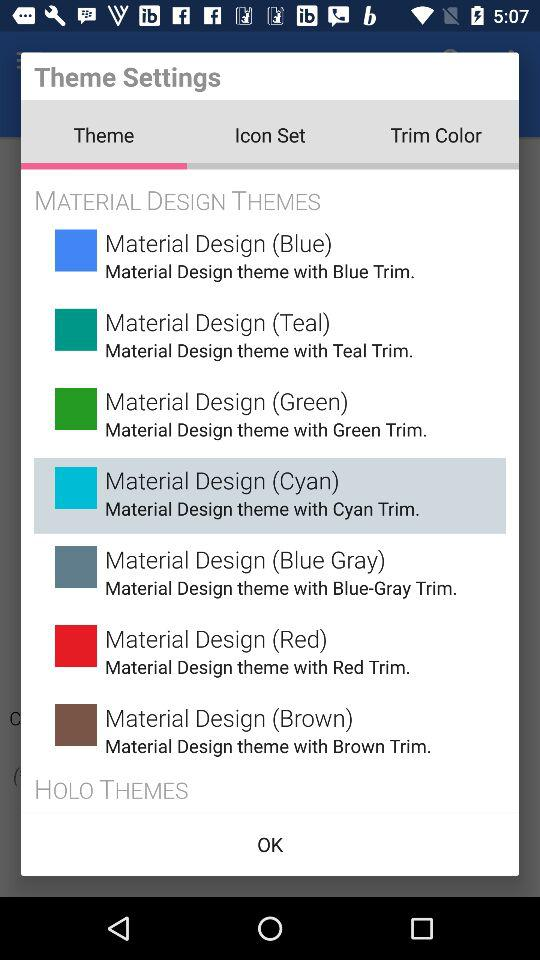Which theme is selected? The selected theme is "Material Design (Cyan)". 